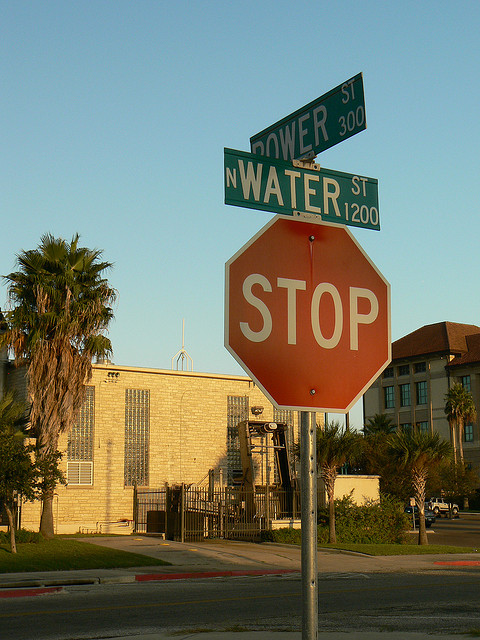<image>What kind of flowers are blooming? There are no flowers blooming in the image. What kind of flowers are blooming? I don't know what kind of flowers are blooming. I can't see any flowers in the image. 